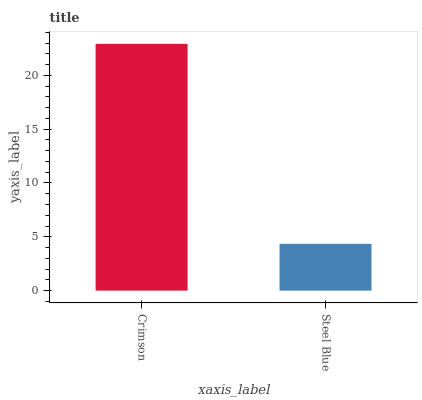Is Steel Blue the minimum?
Answer yes or no. Yes. Is Crimson the maximum?
Answer yes or no. Yes. Is Steel Blue the maximum?
Answer yes or no. No. Is Crimson greater than Steel Blue?
Answer yes or no. Yes. Is Steel Blue less than Crimson?
Answer yes or no. Yes. Is Steel Blue greater than Crimson?
Answer yes or no. No. Is Crimson less than Steel Blue?
Answer yes or no. No. Is Crimson the high median?
Answer yes or no. Yes. Is Steel Blue the low median?
Answer yes or no. Yes. Is Steel Blue the high median?
Answer yes or no. No. Is Crimson the low median?
Answer yes or no. No. 